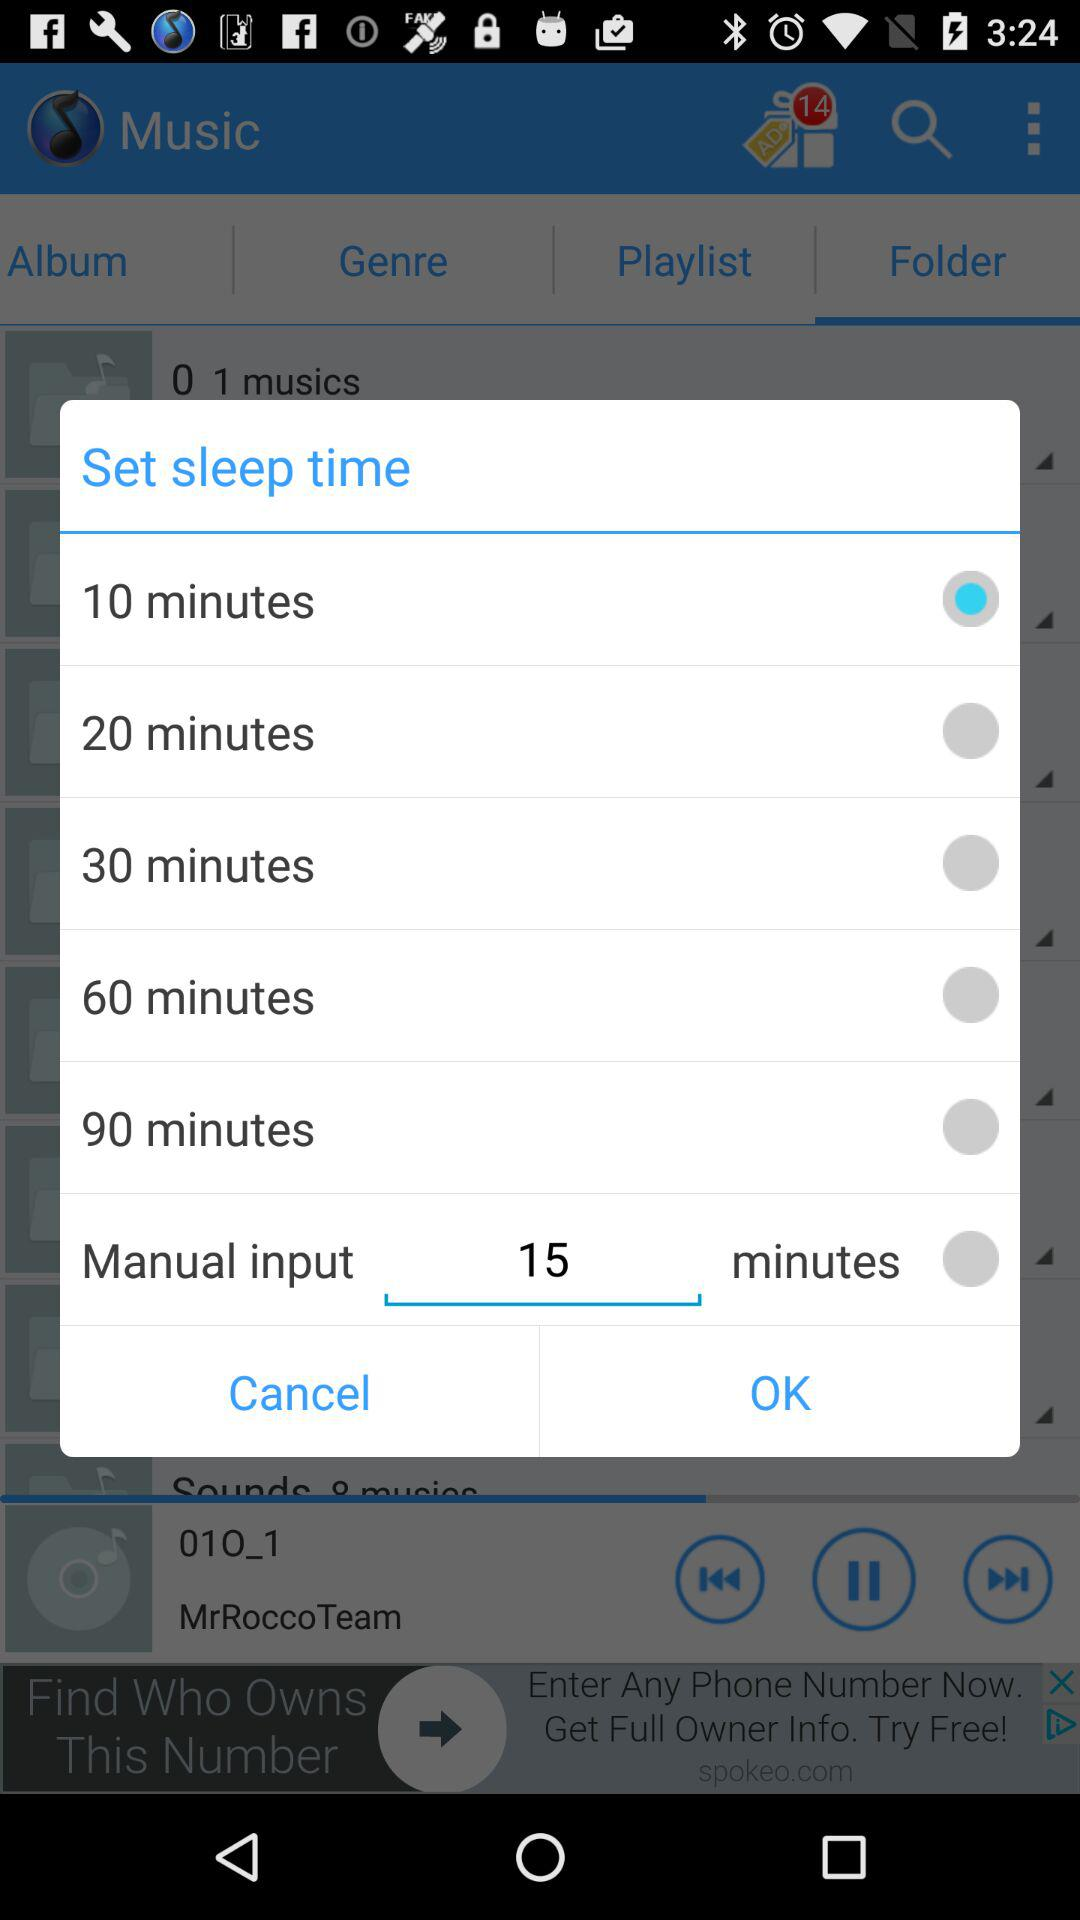What option is selected for "Set sleep time"? The option that is selected for "Set sleep time" is "10 minutes". 